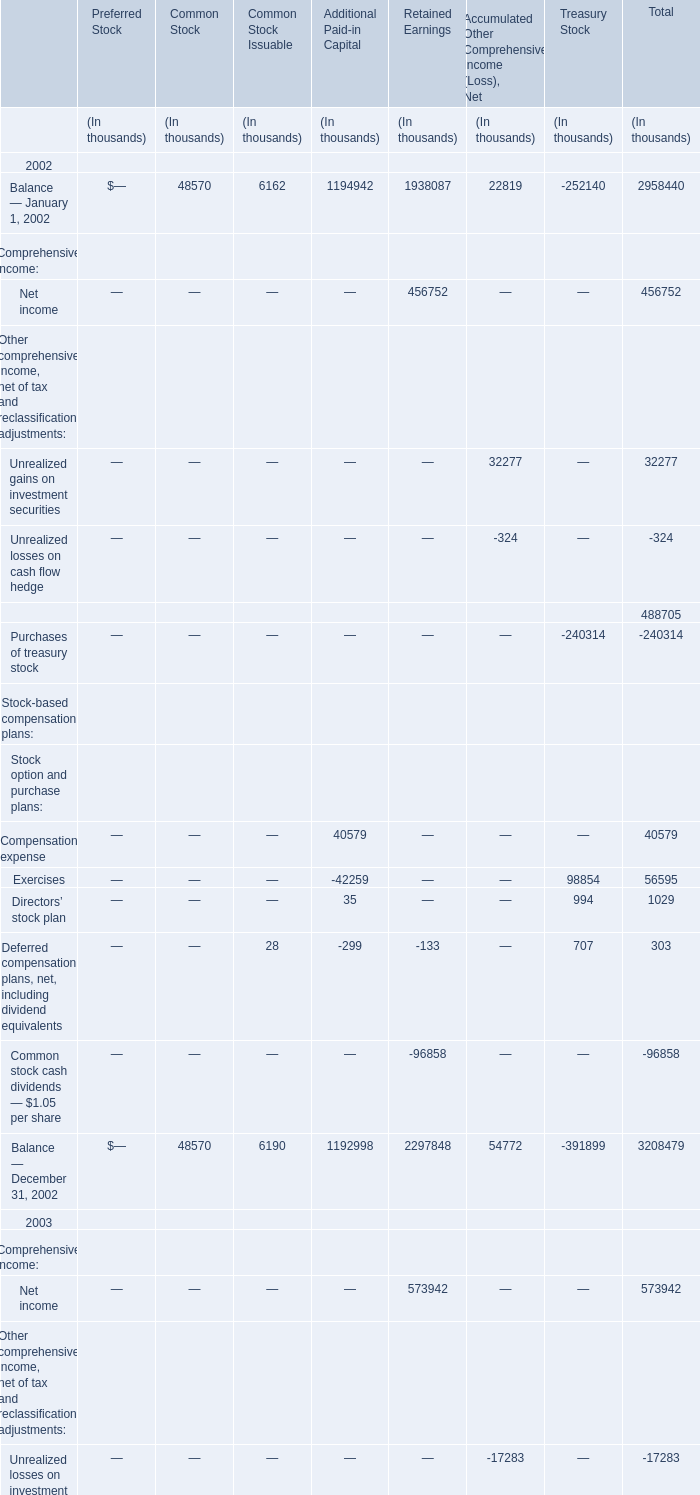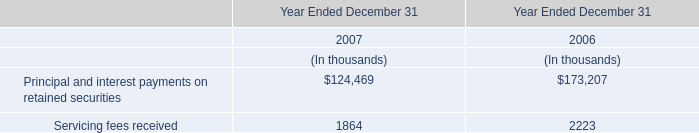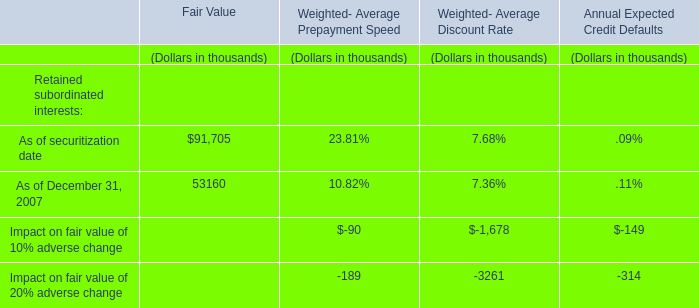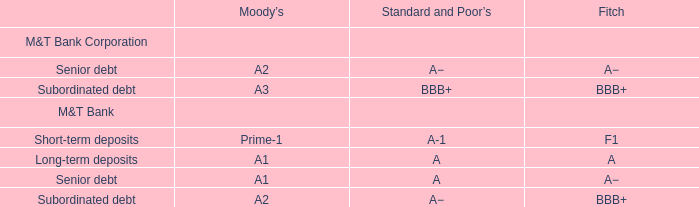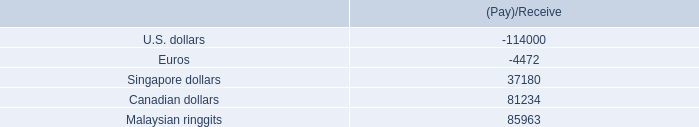What is the percentage of Balance — January 1, 2002 in relation to the total in 2002 for Common Stock? 
Computations: (48570 / 48570)
Answer: 1.0. 